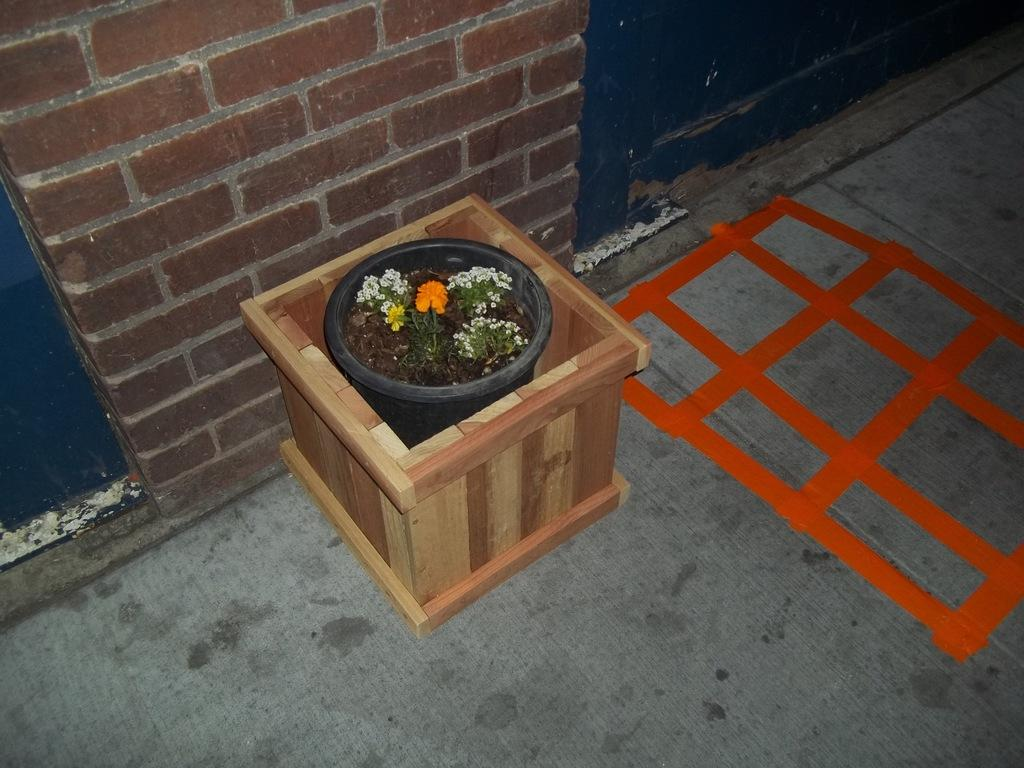What type of plant is in the image? There is a plant with flowers in the image. How is the plant contained or displayed? The plant is in a pot. What other object can be seen on the floor in the image? There is a wooden box on the floor in the image. What type of wall is visible in the background of the image? There is a brick wall in the background of the image. What color is the background of the image? The background has a blue color. Where is the distribution center located in the image? There is no distribution center present in the image. What type of bedroom can be seen in the image? There is no bedroom present in the image. 